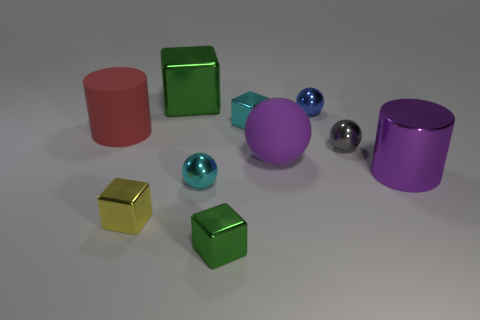How many things are balls that are to the left of the tiny blue metallic thing or tiny things behind the large purple shiny cylinder?
Your answer should be very brief. 5. The big block is what color?
Provide a succinct answer. Green. Are there fewer cyan metallic blocks left of the large purple rubber thing than shiny objects?
Ensure brevity in your answer.  Yes. Are there any other things that are the same shape as the tiny yellow thing?
Keep it short and to the point. Yes. Are there any tiny cylinders?
Give a very brief answer. No. Are there fewer yellow matte cubes than gray metallic objects?
Provide a short and direct response. Yes. What number of red cylinders are the same material as the tiny cyan cube?
Provide a succinct answer. 0. What color is the cylinder that is the same material as the yellow object?
Your response must be concise. Purple. The gray thing is what shape?
Make the answer very short. Sphere. What number of objects have the same color as the rubber sphere?
Your answer should be very brief. 1. 